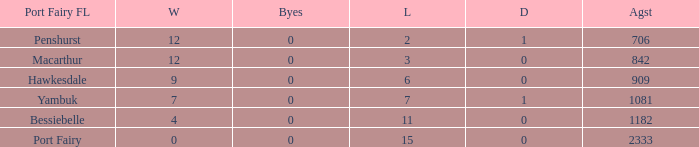How many byes when the draws are less than 0? 0.0. 